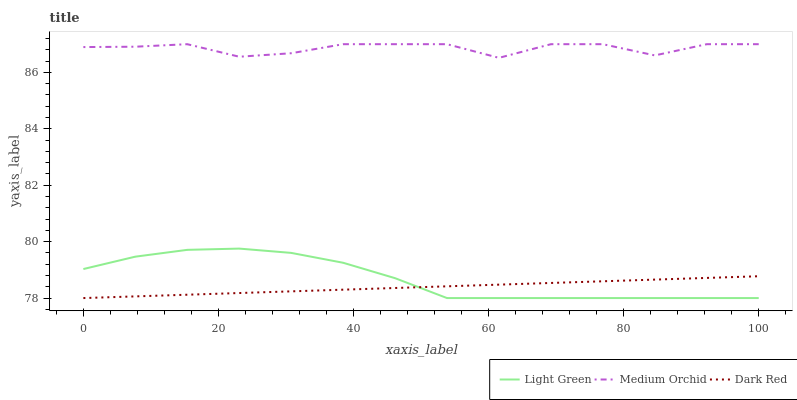Does Dark Red have the minimum area under the curve?
Answer yes or no. Yes. Does Medium Orchid have the maximum area under the curve?
Answer yes or no. Yes. Does Light Green have the minimum area under the curve?
Answer yes or no. No. Does Light Green have the maximum area under the curve?
Answer yes or no. No. Is Dark Red the smoothest?
Answer yes or no. Yes. Is Medium Orchid the roughest?
Answer yes or no. Yes. Is Light Green the smoothest?
Answer yes or no. No. Is Light Green the roughest?
Answer yes or no. No. Does Dark Red have the lowest value?
Answer yes or no. Yes. Does Medium Orchid have the lowest value?
Answer yes or no. No. Does Medium Orchid have the highest value?
Answer yes or no. Yes. Does Light Green have the highest value?
Answer yes or no. No. Is Light Green less than Medium Orchid?
Answer yes or no. Yes. Is Medium Orchid greater than Dark Red?
Answer yes or no. Yes. Does Light Green intersect Dark Red?
Answer yes or no. Yes. Is Light Green less than Dark Red?
Answer yes or no. No. Is Light Green greater than Dark Red?
Answer yes or no. No. Does Light Green intersect Medium Orchid?
Answer yes or no. No. 